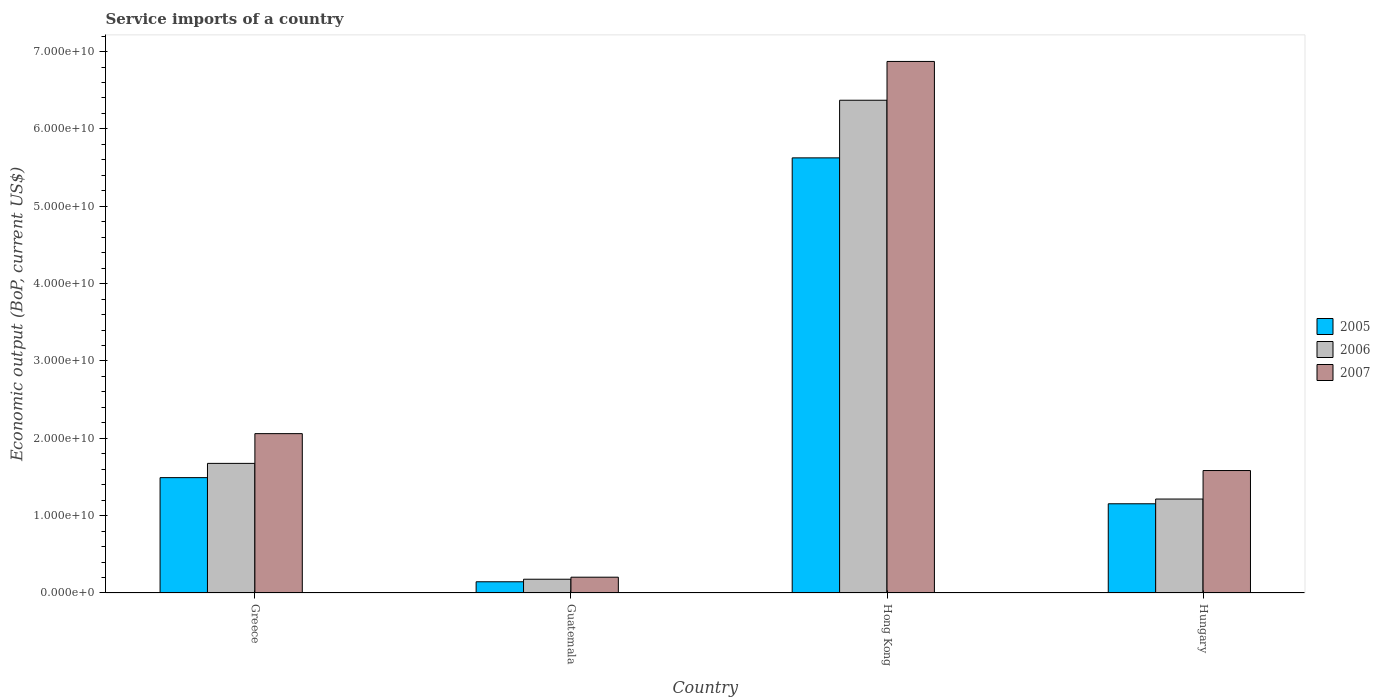How many different coloured bars are there?
Your response must be concise. 3. How many groups of bars are there?
Keep it short and to the point. 4. Are the number of bars per tick equal to the number of legend labels?
Offer a very short reply. Yes. How many bars are there on the 4th tick from the right?
Your response must be concise. 3. What is the label of the 4th group of bars from the left?
Your answer should be compact. Hungary. In how many cases, is the number of bars for a given country not equal to the number of legend labels?
Provide a succinct answer. 0. What is the service imports in 2005 in Hong Kong?
Your response must be concise. 5.63e+1. Across all countries, what is the maximum service imports in 2006?
Your answer should be compact. 6.37e+1. Across all countries, what is the minimum service imports in 2006?
Offer a very short reply. 1.78e+09. In which country was the service imports in 2007 maximum?
Offer a terse response. Hong Kong. In which country was the service imports in 2005 minimum?
Your response must be concise. Guatemala. What is the total service imports in 2007 in the graph?
Provide a short and direct response. 1.07e+11. What is the difference between the service imports in 2006 in Guatemala and that in Hong Kong?
Ensure brevity in your answer.  -6.19e+1. What is the difference between the service imports in 2007 in Greece and the service imports in 2006 in Hungary?
Provide a succinct answer. 8.46e+09. What is the average service imports in 2005 per country?
Offer a very short reply. 2.10e+1. What is the difference between the service imports of/in 2007 and service imports of/in 2006 in Guatemala?
Give a very brief answer. 2.63e+08. What is the ratio of the service imports in 2006 in Guatemala to that in Hong Kong?
Provide a succinct answer. 0.03. Is the service imports in 2007 in Hong Kong less than that in Hungary?
Your answer should be compact. No. What is the difference between the highest and the second highest service imports in 2006?
Offer a terse response. 4.69e+1. What is the difference between the highest and the lowest service imports in 2006?
Your response must be concise. 6.19e+1. In how many countries, is the service imports in 2006 greater than the average service imports in 2006 taken over all countries?
Offer a terse response. 1. What does the 2nd bar from the right in Hong Kong represents?
Keep it short and to the point. 2006. Is it the case that in every country, the sum of the service imports in 2006 and service imports in 2007 is greater than the service imports in 2005?
Provide a succinct answer. Yes. What is the difference between two consecutive major ticks on the Y-axis?
Offer a terse response. 1.00e+1. Are the values on the major ticks of Y-axis written in scientific E-notation?
Offer a terse response. Yes. Does the graph contain any zero values?
Offer a very short reply. No. Where does the legend appear in the graph?
Ensure brevity in your answer.  Center right. How many legend labels are there?
Keep it short and to the point. 3. How are the legend labels stacked?
Ensure brevity in your answer.  Vertical. What is the title of the graph?
Make the answer very short. Service imports of a country. Does "2006" appear as one of the legend labels in the graph?
Offer a very short reply. Yes. What is the label or title of the Y-axis?
Your answer should be very brief. Economic output (BoP, current US$). What is the Economic output (BoP, current US$) in 2005 in Greece?
Your answer should be very brief. 1.49e+1. What is the Economic output (BoP, current US$) in 2006 in Greece?
Give a very brief answer. 1.68e+1. What is the Economic output (BoP, current US$) of 2007 in Greece?
Give a very brief answer. 2.06e+1. What is the Economic output (BoP, current US$) of 2005 in Guatemala?
Keep it short and to the point. 1.45e+09. What is the Economic output (BoP, current US$) in 2006 in Guatemala?
Provide a short and direct response. 1.78e+09. What is the Economic output (BoP, current US$) of 2007 in Guatemala?
Your answer should be compact. 2.04e+09. What is the Economic output (BoP, current US$) in 2005 in Hong Kong?
Your response must be concise. 5.63e+1. What is the Economic output (BoP, current US$) in 2006 in Hong Kong?
Make the answer very short. 6.37e+1. What is the Economic output (BoP, current US$) in 2007 in Hong Kong?
Give a very brief answer. 6.87e+1. What is the Economic output (BoP, current US$) in 2005 in Hungary?
Your answer should be very brief. 1.15e+1. What is the Economic output (BoP, current US$) in 2006 in Hungary?
Your answer should be compact. 1.21e+1. What is the Economic output (BoP, current US$) of 2007 in Hungary?
Your response must be concise. 1.58e+1. Across all countries, what is the maximum Economic output (BoP, current US$) of 2005?
Offer a very short reply. 5.63e+1. Across all countries, what is the maximum Economic output (BoP, current US$) of 2006?
Your answer should be very brief. 6.37e+1. Across all countries, what is the maximum Economic output (BoP, current US$) of 2007?
Offer a terse response. 6.87e+1. Across all countries, what is the minimum Economic output (BoP, current US$) of 2005?
Provide a short and direct response. 1.45e+09. Across all countries, what is the minimum Economic output (BoP, current US$) in 2006?
Provide a short and direct response. 1.78e+09. Across all countries, what is the minimum Economic output (BoP, current US$) of 2007?
Your answer should be compact. 2.04e+09. What is the total Economic output (BoP, current US$) in 2005 in the graph?
Your answer should be very brief. 8.42e+1. What is the total Economic output (BoP, current US$) of 2006 in the graph?
Ensure brevity in your answer.  9.44e+1. What is the total Economic output (BoP, current US$) of 2007 in the graph?
Your answer should be very brief. 1.07e+11. What is the difference between the Economic output (BoP, current US$) of 2005 in Greece and that in Guatemala?
Keep it short and to the point. 1.35e+1. What is the difference between the Economic output (BoP, current US$) in 2006 in Greece and that in Guatemala?
Offer a terse response. 1.50e+1. What is the difference between the Economic output (BoP, current US$) of 2007 in Greece and that in Guatemala?
Offer a very short reply. 1.86e+1. What is the difference between the Economic output (BoP, current US$) in 2005 in Greece and that in Hong Kong?
Your answer should be compact. -4.13e+1. What is the difference between the Economic output (BoP, current US$) of 2006 in Greece and that in Hong Kong?
Ensure brevity in your answer.  -4.69e+1. What is the difference between the Economic output (BoP, current US$) in 2007 in Greece and that in Hong Kong?
Your response must be concise. -4.81e+1. What is the difference between the Economic output (BoP, current US$) in 2005 in Greece and that in Hungary?
Your answer should be compact. 3.38e+09. What is the difference between the Economic output (BoP, current US$) of 2006 in Greece and that in Hungary?
Offer a very short reply. 4.61e+09. What is the difference between the Economic output (BoP, current US$) of 2007 in Greece and that in Hungary?
Offer a very short reply. 4.77e+09. What is the difference between the Economic output (BoP, current US$) of 2005 in Guatemala and that in Hong Kong?
Keep it short and to the point. -5.48e+1. What is the difference between the Economic output (BoP, current US$) of 2006 in Guatemala and that in Hong Kong?
Give a very brief answer. -6.19e+1. What is the difference between the Economic output (BoP, current US$) of 2007 in Guatemala and that in Hong Kong?
Your answer should be very brief. -6.67e+1. What is the difference between the Economic output (BoP, current US$) in 2005 in Guatemala and that in Hungary?
Ensure brevity in your answer.  -1.01e+1. What is the difference between the Economic output (BoP, current US$) of 2006 in Guatemala and that in Hungary?
Offer a very short reply. -1.04e+1. What is the difference between the Economic output (BoP, current US$) in 2007 in Guatemala and that in Hungary?
Offer a very short reply. -1.38e+1. What is the difference between the Economic output (BoP, current US$) of 2005 in Hong Kong and that in Hungary?
Provide a succinct answer. 4.47e+1. What is the difference between the Economic output (BoP, current US$) in 2006 in Hong Kong and that in Hungary?
Provide a succinct answer. 5.16e+1. What is the difference between the Economic output (BoP, current US$) of 2007 in Hong Kong and that in Hungary?
Your answer should be very brief. 5.29e+1. What is the difference between the Economic output (BoP, current US$) of 2005 in Greece and the Economic output (BoP, current US$) of 2006 in Guatemala?
Offer a terse response. 1.31e+1. What is the difference between the Economic output (BoP, current US$) in 2005 in Greece and the Economic output (BoP, current US$) in 2007 in Guatemala?
Provide a succinct answer. 1.29e+1. What is the difference between the Economic output (BoP, current US$) of 2006 in Greece and the Economic output (BoP, current US$) of 2007 in Guatemala?
Provide a short and direct response. 1.47e+1. What is the difference between the Economic output (BoP, current US$) of 2005 in Greece and the Economic output (BoP, current US$) of 2006 in Hong Kong?
Offer a very short reply. -4.88e+1. What is the difference between the Economic output (BoP, current US$) in 2005 in Greece and the Economic output (BoP, current US$) in 2007 in Hong Kong?
Ensure brevity in your answer.  -5.38e+1. What is the difference between the Economic output (BoP, current US$) of 2006 in Greece and the Economic output (BoP, current US$) of 2007 in Hong Kong?
Ensure brevity in your answer.  -5.20e+1. What is the difference between the Economic output (BoP, current US$) of 2005 in Greece and the Economic output (BoP, current US$) of 2006 in Hungary?
Make the answer very short. 2.77e+09. What is the difference between the Economic output (BoP, current US$) of 2005 in Greece and the Economic output (BoP, current US$) of 2007 in Hungary?
Your response must be concise. -9.18e+08. What is the difference between the Economic output (BoP, current US$) of 2006 in Greece and the Economic output (BoP, current US$) of 2007 in Hungary?
Make the answer very short. 9.25e+08. What is the difference between the Economic output (BoP, current US$) in 2005 in Guatemala and the Economic output (BoP, current US$) in 2006 in Hong Kong?
Provide a succinct answer. -6.23e+1. What is the difference between the Economic output (BoP, current US$) of 2005 in Guatemala and the Economic output (BoP, current US$) of 2007 in Hong Kong?
Keep it short and to the point. -6.73e+1. What is the difference between the Economic output (BoP, current US$) in 2006 in Guatemala and the Economic output (BoP, current US$) in 2007 in Hong Kong?
Give a very brief answer. -6.69e+1. What is the difference between the Economic output (BoP, current US$) in 2005 in Guatemala and the Economic output (BoP, current US$) in 2006 in Hungary?
Give a very brief answer. -1.07e+1. What is the difference between the Economic output (BoP, current US$) of 2005 in Guatemala and the Economic output (BoP, current US$) of 2007 in Hungary?
Give a very brief answer. -1.44e+1. What is the difference between the Economic output (BoP, current US$) of 2006 in Guatemala and the Economic output (BoP, current US$) of 2007 in Hungary?
Your response must be concise. -1.41e+1. What is the difference between the Economic output (BoP, current US$) in 2005 in Hong Kong and the Economic output (BoP, current US$) in 2006 in Hungary?
Make the answer very short. 4.41e+1. What is the difference between the Economic output (BoP, current US$) in 2005 in Hong Kong and the Economic output (BoP, current US$) in 2007 in Hungary?
Offer a terse response. 4.04e+1. What is the difference between the Economic output (BoP, current US$) of 2006 in Hong Kong and the Economic output (BoP, current US$) of 2007 in Hungary?
Make the answer very short. 4.79e+1. What is the average Economic output (BoP, current US$) of 2005 per country?
Ensure brevity in your answer.  2.10e+1. What is the average Economic output (BoP, current US$) in 2006 per country?
Keep it short and to the point. 2.36e+1. What is the average Economic output (BoP, current US$) in 2007 per country?
Offer a terse response. 2.68e+1. What is the difference between the Economic output (BoP, current US$) of 2005 and Economic output (BoP, current US$) of 2006 in Greece?
Your response must be concise. -1.84e+09. What is the difference between the Economic output (BoP, current US$) of 2005 and Economic output (BoP, current US$) of 2007 in Greece?
Make the answer very short. -5.69e+09. What is the difference between the Economic output (BoP, current US$) of 2006 and Economic output (BoP, current US$) of 2007 in Greece?
Provide a succinct answer. -3.85e+09. What is the difference between the Economic output (BoP, current US$) of 2005 and Economic output (BoP, current US$) of 2006 in Guatemala?
Your answer should be very brief. -3.29e+08. What is the difference between the Economic output (BoP, current US$) of 2005 and Economic output (BoP, current US$) of 2007 in Guatemala?
Your answer should be compact. -5.92e+08. What is the difference between the Economic output (BoP, current US$) in 2006 and Economic output (BoP, current US$) in 2007 in Guatemala?
Your answer should be very brief. -2.63e+08. What is the difference between the Economic output (BoP, current US$) of 2005 and Economic output (BoP, current US$) of 2006 in Hong Kong?
Keep it short and to the point. -7.45e+09. What is the difference between the Economic output (BoP, current US$) of 2005 and Economic output (BoP, current US$) of 2007 in Hong Kong?
Offer a very short reply. -1.25e+1. What is the difference between the Economic output (BoP, current US$) of 2006 and Economic output (BoP, current US$) of 2007 in Hong Kong?
Your answer should be compact. -5.01e+09. What is the difference between the Economic output (BoP, current US$) of 2005 and Economic output (BoP, current US$) of 2006 in Hungary?
Keep it short and to the point. -6.10e+08. What is the difference between the Economic output (BoP, current US$) of 2005 and Economic output (BoP, current US$) of 2007 in Hungary?
Offer a terse response. -4.30e+09. What is the difference between the Economic output (BoP, current US$) of 2006 and Economic output (BoP, current US$) of 2007 in Hungary?
Your response must be concise. -3.69e+09. What is the ratio of the Economic output (BoP, current US$) in 2005 in Greece to that in Guatemala?
Your answer should be very brief. 10.29. What is the ratio of the Economic output (BoP, current US$) in 2006 in Greece to that in Guatemala?
Provide a short and direct response. 9.42. What is the ratio of the Economic output (BoP, current US$) in 2007 in Greece to that in Guatemala?
Make the answer very short. 10.09. What is the ratio of the Economic output (BoP, current US$) of 2005 in Greece to that in Hong Kong?
Provide a succinct answer. 0.27. What is the ratio of the Economic output (BoP, current US$) of 2006 in Greece to that in Hong Kong?
Keep it short and to the point. 0.26. What is the ratio of the Economic output (BoP, current US$) in 2007 in Greece to that in Hong Kong?
Provide a short and direct response. 0.3. What is the ratio of the Economic output (BoP, current US$) in 2005 in Greece to that in Hungary?
Give a very brief answer. 1.29. What is the ratio of the Economic output (BoP, current US$) of 2006 in Greece to that in Hungary?
Keep it short and to the point. 1.38. What is the ratio of the Economic output (BoP, current US$) of 2007 in Greece to that in Hungary?
Provide a succinct answer. 1.3. What is the ratio of the Economic output (BoP, current US$) of 2005 in Guatemala to that in Hong Kong?
Offer a very short reply. 0.03. What is the ratio of the Economic output (BoP, current US$) of 2006 in Guatemala to that in Hong Kong?
Provide a short and direct response. 0.03. What is the ratio of the Economic output (BoP, current US$) of 2007 in Guatemala to that in Hong Kong?
Your answer should be compact. 0.03. What is the ratio of the Economic output (BoP, current US$) in 2005 in Guatemala to that in Hungary?
Ensure brevity in your answer.  0.13. What is the ratio of the Economic output (BoP, current US$) of 2006 in Guatemala to that in Hungary?
Provide a short and direct response. 0.15. What is the ratio of the Economic output (BoP, current US$) of 2007 in Guatemala to that in Hungary?
Offer a terse response. 0.13. What is the ratio of the Economic output (BoP, current US$) of 2005 in Hong Kong to that in Hungary?
Offer a terse response. 4.88. What is the ratio of the Economic output (BoP, current US$) of 2006 in Hong Kong to that in Hungary?
Your answer should be compact. 5.25. What is the ratio of the Economic output (BoP, current US$) in 2007 in Hong Kong to that in Hungary?
Make the answer very short. 4.34. What is the difference between the highest and the second highest Economic output (BoP, current US$) in 2005?
Ensure brevity in your answer.  4.13e+1. What is the difference between the highest and the second highest Economic output (BoP, current US$) in 2006?
Your response must be concise. 4.69e+1. What is the difference between the highest and the second highest Economic output (BoP, current US$) of 2007?
Ensure brevity in your answer.  4.81e+1. What is the difference between the highest and the lowest Economic output (BoP, current US$) of 2005?
Your answer should be very brief. 5.48e+1. What is the difference between the highest and the lowest Economic output (BoP, current US$) in 2006?
Your answer should be very brief. 6.19e+1. What is the difference between the highest and the lowest Economic output (BoP, current US$) in 2007?
Offer a terse response. 6.67e+1. 